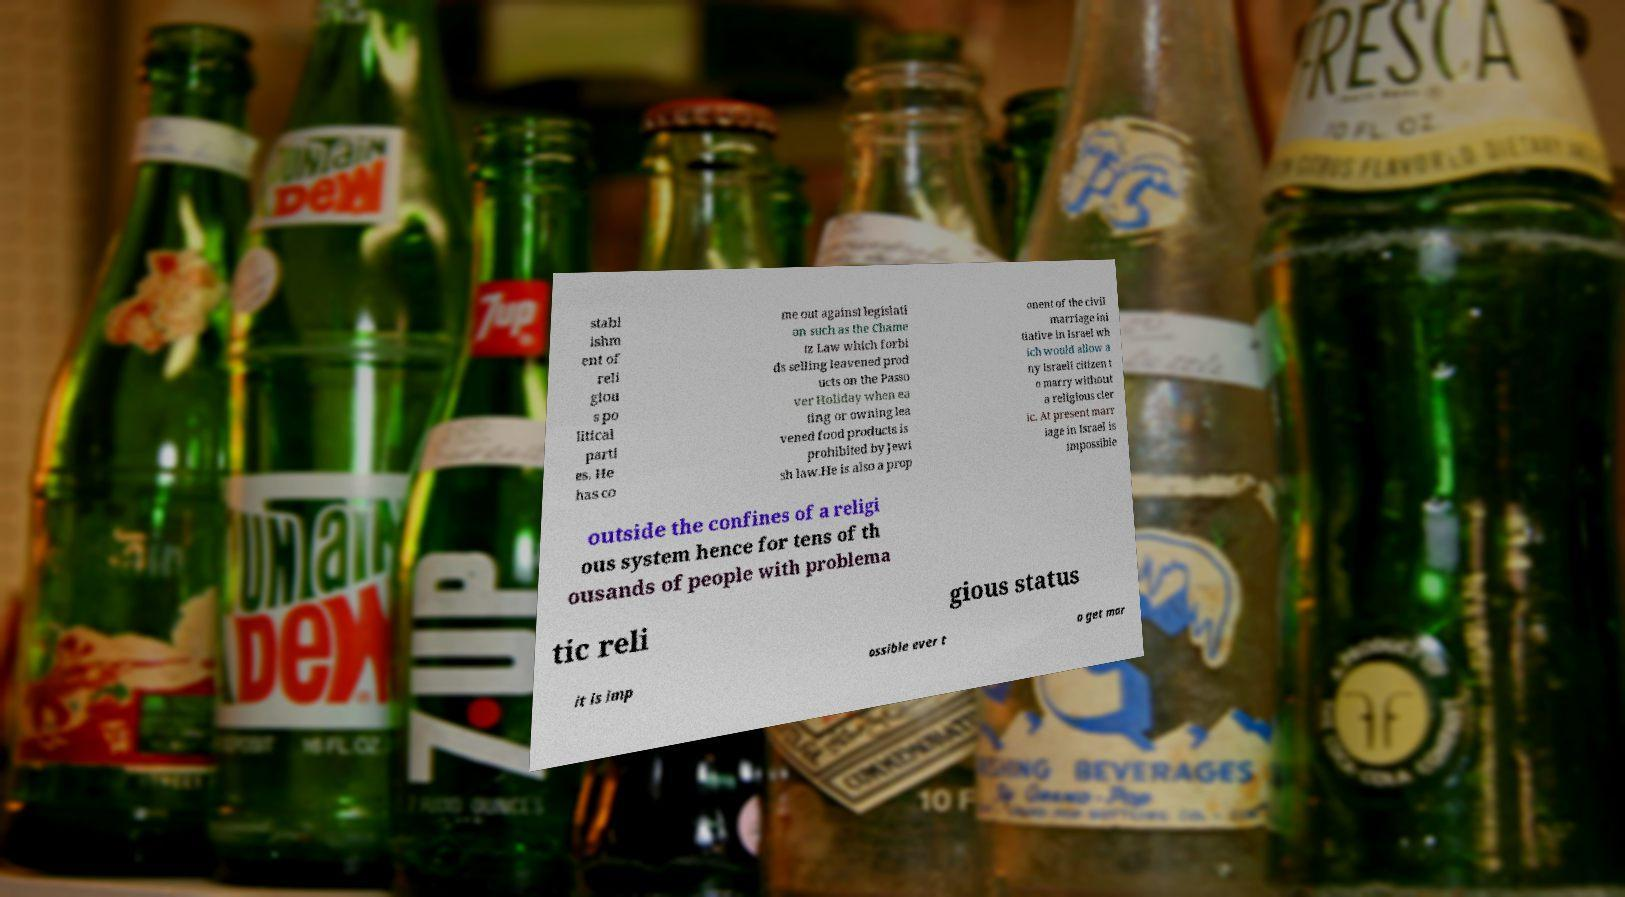Could you assist in decoding the text presented in this image and type it out clearly? stabl ishm ent of reli giou s po litical parti es. He has co me out against legislati on such as the Chame tz Law which forbi ds selling leavened prod ucts on the Passo ver Holiday when ea ting or owning lea vened food products is prohibited by Jewi sh law.He is also a prop onent of the civil marriage ini tiative in Israel wh ich would allow a ny Israeli citizen t o marry without a religious cler ic. At present marr iage in Israel is impossible outside the confines of a religi ous system hence for tens of th ousands of people with problema tic reli gious status it is imp ossible ever t o get mar 